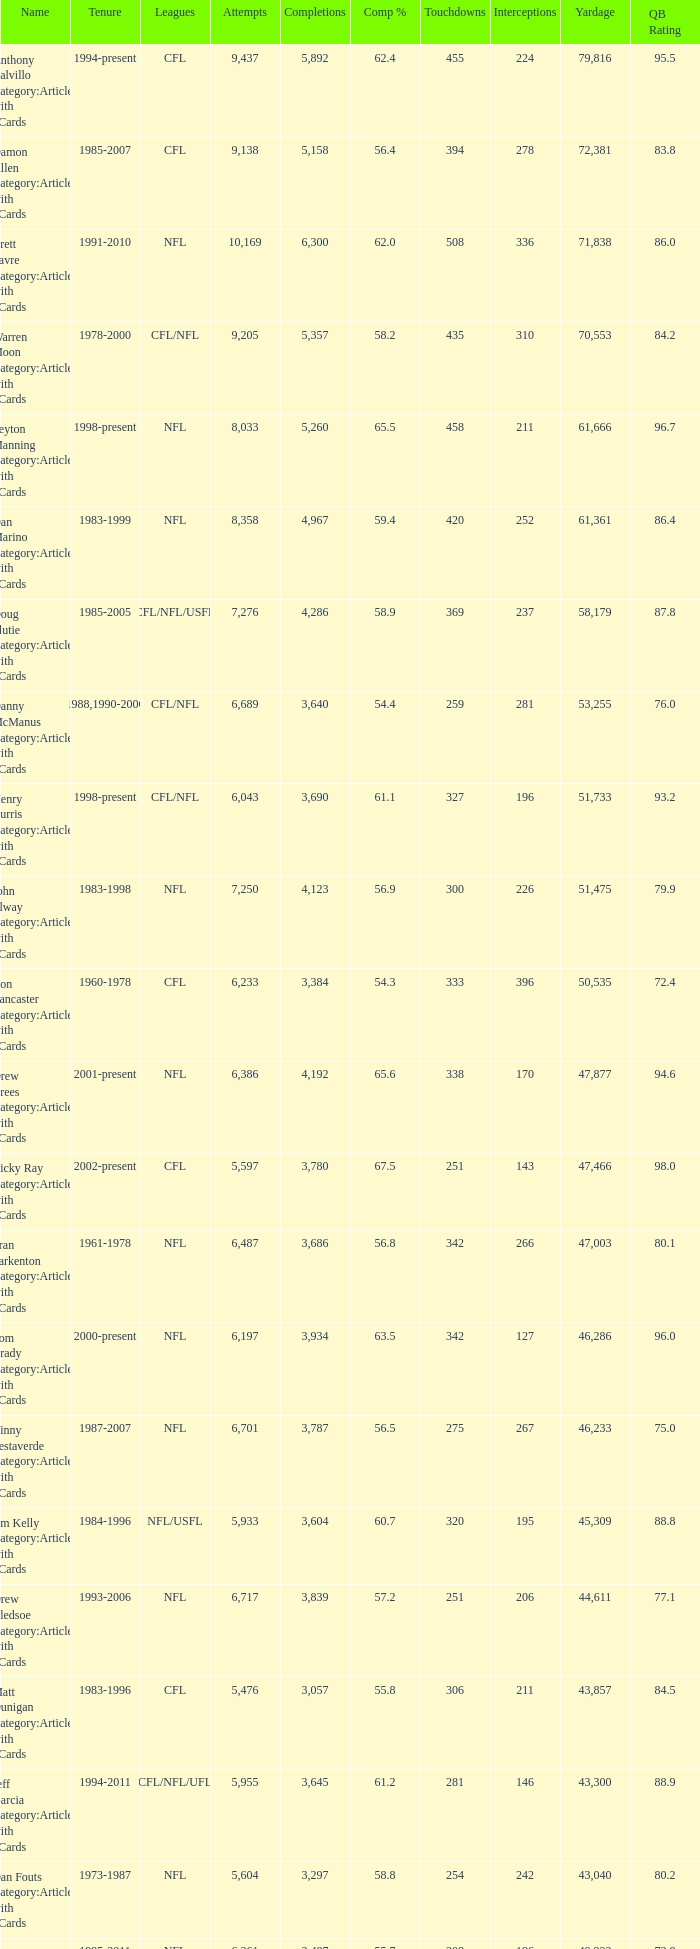What is the comp percentage when there are less than 44,611 in yardage, more than 254 touchdowns, and rank larger than 24? 54.6. 